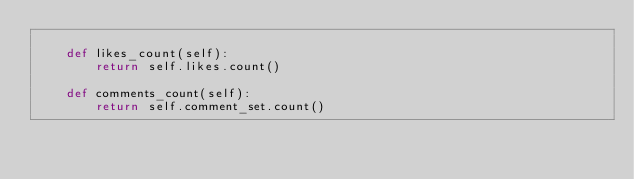Convert code to text. <code><loc_0><loc_0><loc_500><loc_500><_Python_>
    def likes_count(self):
        return self.likes.count()

    def comments_count(self):
        return self.comment_set.count()
</code> 